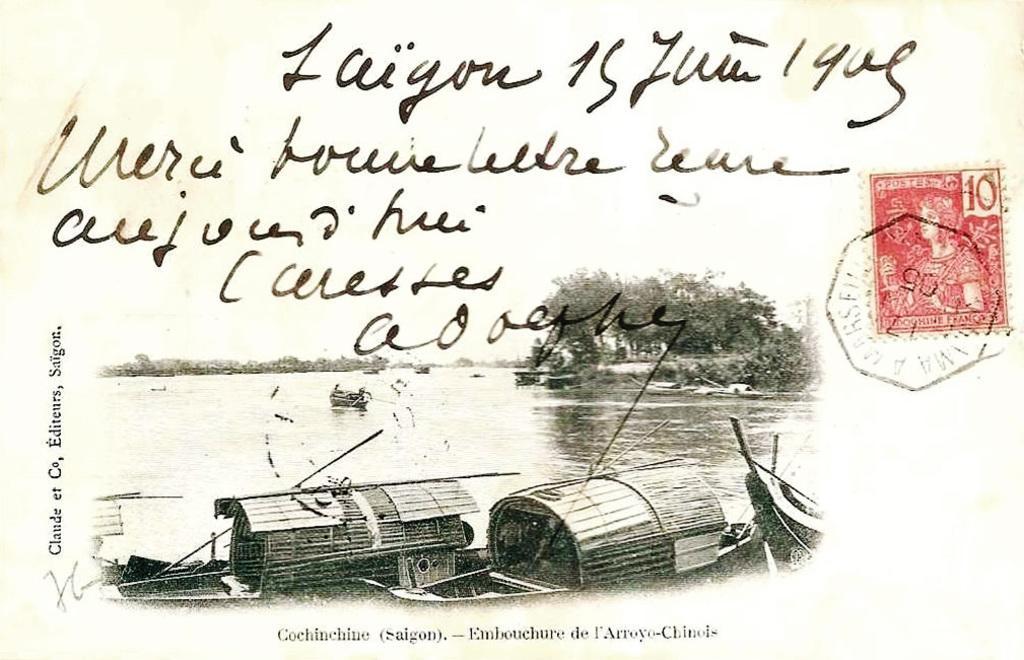Describe this image in one or two sentences. In this picture there is a poster. In the poster I can see some boats on the water. In the background of the poster I can see the trees, plants and grass. At the top of the poster I can see something is written and sky. At the bottom I can see the watermark. On the right I can see the stamps on the poster. 